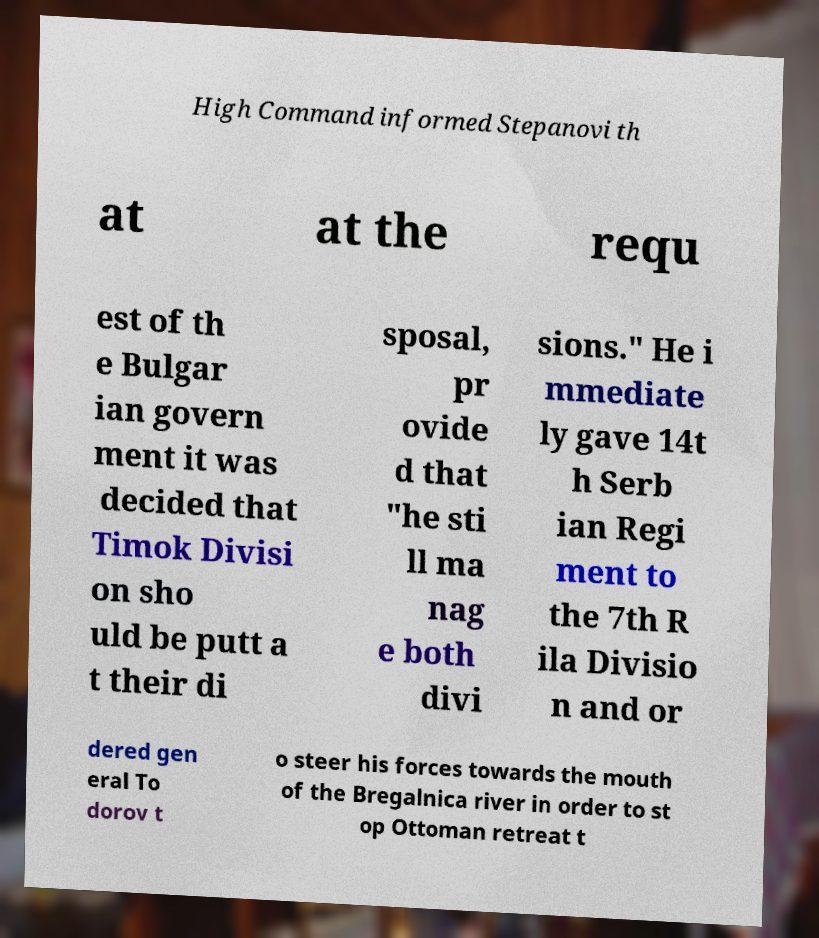There's text embedded in this image that I need extracted. Can you transcribe it verbatim? High Command informed Stepanovi th at at the requ est of th e Bulgar ian govern ment it was decided that Timok Divisi on sho uld be putt a t their di sposal, pr ovide d that ″he sti ll ma nag e both divi sions.″ He i mmediate ly gave 14t h Serb ian Regi ment to the 7th R ila Divisio n and or dered gen eral To dorov t o steer his forces towards the mouth of the Bregalnica river in order to st op Ottoman retreat t 